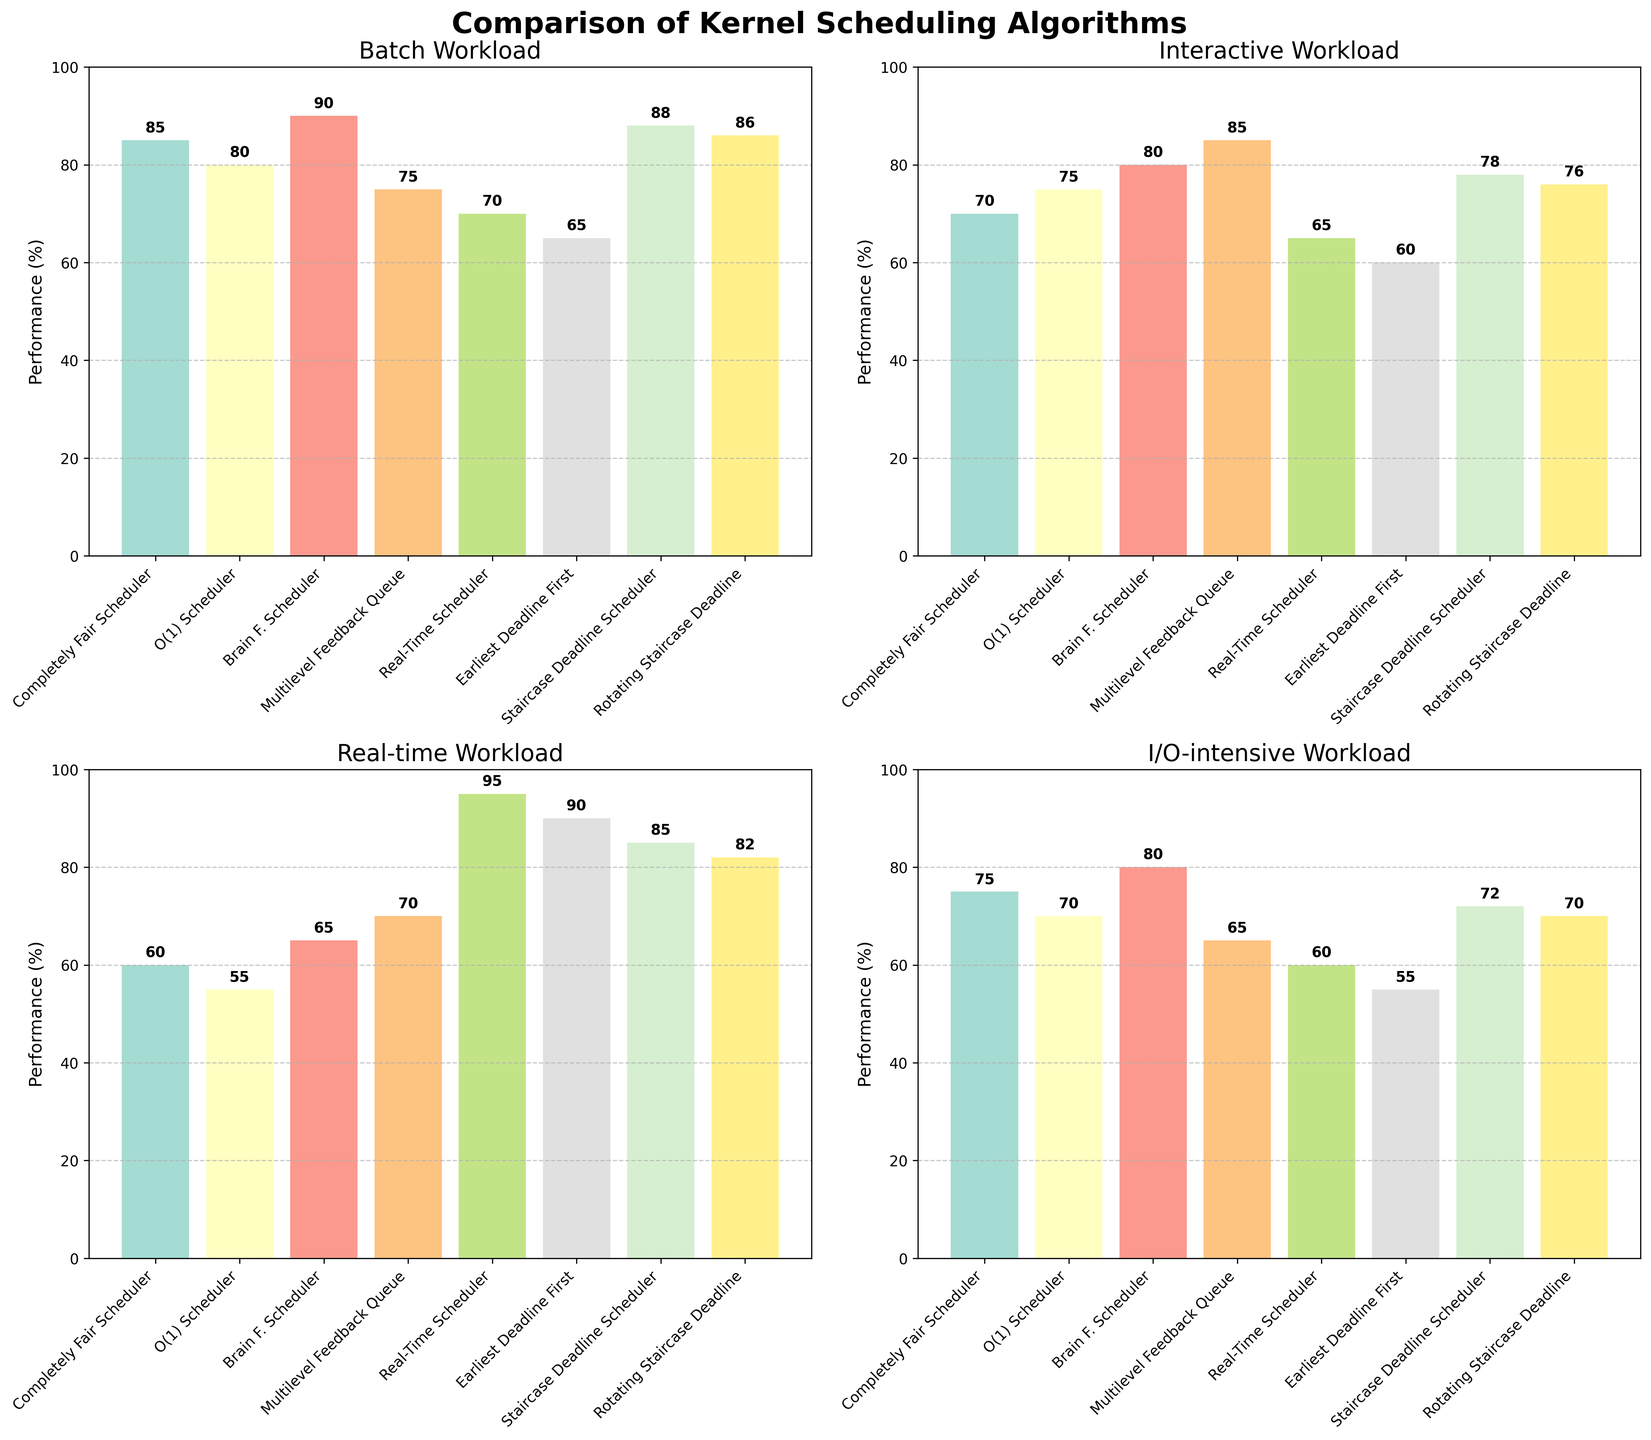What's the title of the figure? The title of the figure is positioned at the top and reads "Comparison of Kernel Scheduling Algorithms”.
Answer: Comparison of Kernel Scheduling Algorithms Which scheduler performs best under the Interactive workload? In the subplot titled 'Interactive Workload', the bar representing Multilevel Feedback Queue (MLFQ) is the highest, indicating the best performance.
Answer: Multilevel Feedback Queue How does the performance of the Real-Time Scheduler compare with the Earliest Deadline First Scheduler under Real-time workloads? In the subplot titled 'Real-time Workload', the Real-Time Scheduler has a performance of 95%, while the Earliest Deadline First Scheduler has a performance of 90%. The Real-Time Scheduler outperforms the Earliest Deadline First Scheduler.
Answer: Real-Time Scheduler performs better Which workload type has the highest variability in performance among different schedulers? By visually comparing the range of heights of the bars in each subplot, the 'Real-time Workload' shows the highest variability, with performances ranging from 55 to 95.
Answer: Real-time What is the average performance of the Staircase Deadline Scheduler across all workload types? To find the average, add the performances of the Staircase Deadline Scheduler (88, 78, 85, 72) and divide by 4: (88+78+85+72)/4 = 323/4 = 80.75.
Answer: 80.75 Which scheduler shows the most consistent performance across all workload types? By visually comparing the heights of the bars, the Brain F. Scheduler appears the most consistent with performances of 90, 80, 65, and 80, showing the smallest range among other schedulers.
Answer: Brain F. Scheduler How much better is the Brain F. Scheduler than the Completely Fair Scheduler in I/O-intensive workloads? In the 'I/O-intensive Workload' subplot, Brain F. Scheduler has a performance of 80% and the Completely Fair Scheduler has 75%. The difference is 80 - 75 = 5%.
Answer: 5% Under which workload type does the Rotating Staircase Deadline Scheduler perform better than the Multilevel Feedback Queue but worse than the Brain F. Scheduler? In the 'I/O-intensive Workload' subplot, Rotating Staircase Deadline Scheduler (70) performs better than Multilevel Feedback Queue (65) but worse than Brain F. Scheduler (80).
Answer: I/O-intensive Which scheduler underperforms in the Batch workload compared to others? In the 'Batch Workload' subplot, the Earliest Deadline First scheduler has the lowest performance at 65%, underperforming compared to others.
Answer: Earliest Deadline First 